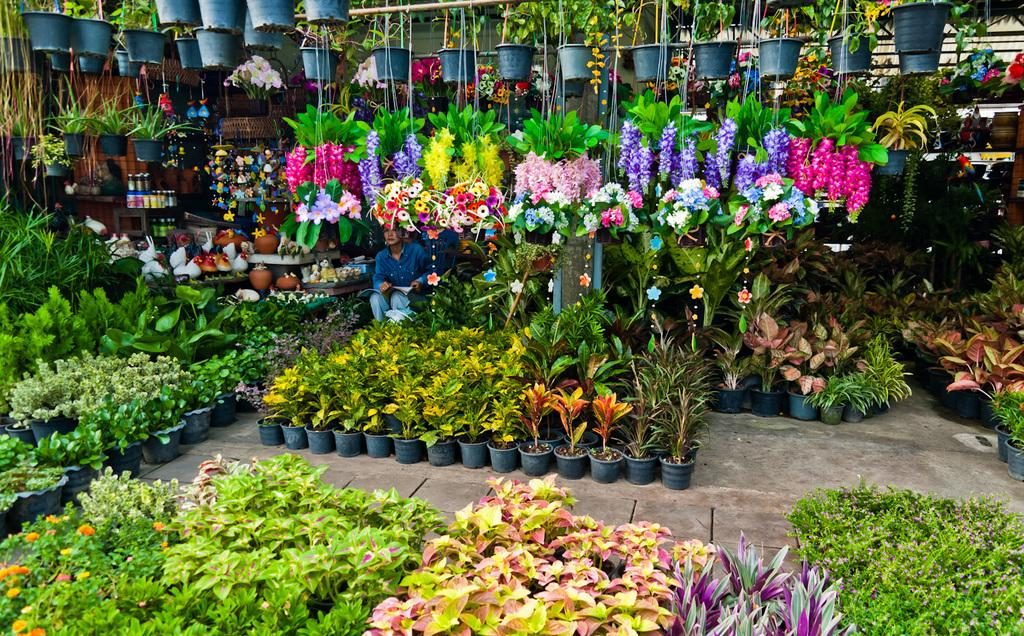What is the person in the image doing? The person is sitting in the image. What is the person holding in the image? The person is holding a book. What type of vegetation can be seen in the image? There are potted plants and flowers in the image. What type of containers are visible in the image? There are jars in the image. Can you describe any other objects in the image? There are other objects in the image, but their specific details are not mentioned in the provided facts. What type of gate can be seen in the image? There is no gate present in the image. How many hens are visible in the image? There are no hens present in the image. 